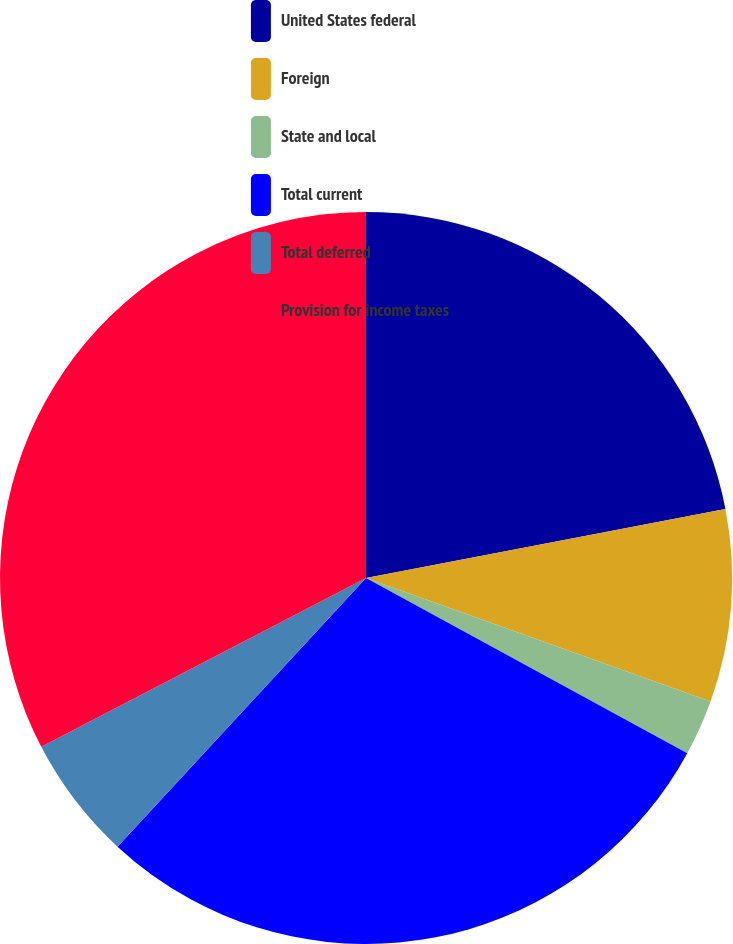Convert chart to OTSL. <chart><loc_0><loc_0><loc_500><loc_500><pie_chart><fcel>United States federal<fcel>Foreign<fcel>State and local<fcel>Total current<fcel>Total deferred<fcel>Provision for income taxes<nl><fcel>21.98%<fcel>8.5%<fcel>2.47%<fcel>28.93%<fcel>5.49%<fcel>32.63%<nl></chart> 